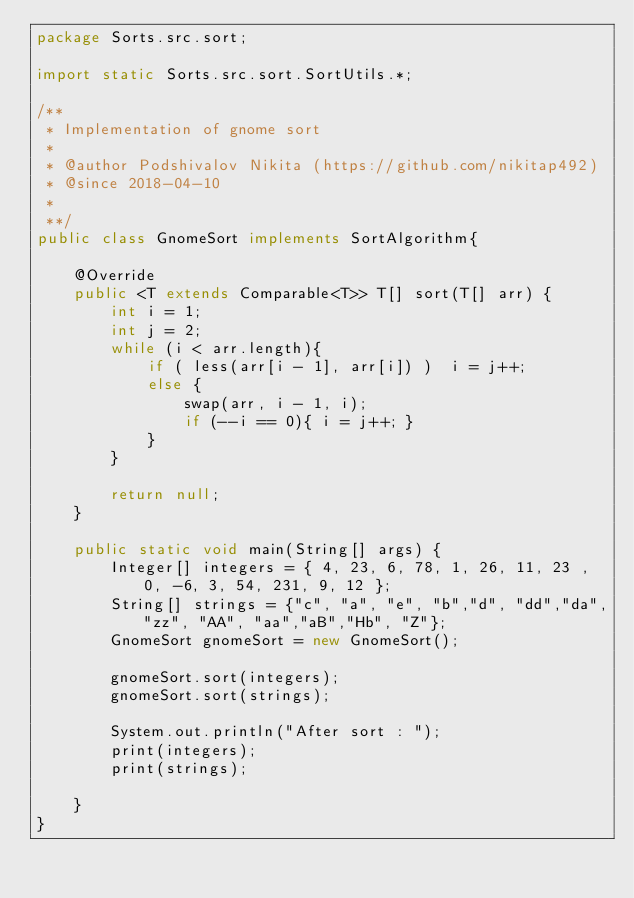Convert code to text. <code><loc_0><loc_0><loc_500><loc_500><_Java_>package Sorts.src.sort;

import static Sorts.src.sort.SortUtils.*;

/**
 * Implementation of gnome sort
 *
 * @author Podshivalov Nikita (https://github.com/nikitap492)
 * @since 2018-04-10
 *
 **/
public class GnomeSort implements SortAlgorithm{

    @Override
    public <T extends Comparable<T>> T[] sort(T[] arr) {
        int i = 1;
        int j = 2;
        while (i < arr.length){
            if ( less(arr[i - 1], arr[i]) )  i = j++;
            else {
                swap(arr, i - 1, i);
                if (--i == 0){ i = j++; }
            }
        }

        return null;
    }

    public static void main(String[] args) {
        Integer[] integers = { 4, 23, 6, 78, 1, 26, 11, 23 , 0, -6, 3, 54, 231, 9, 12 };
        String[] strings = {"c", "a", "e", "b","d", "dd","da","zz", "AA", "aa","aB","Hb", "Z"};
        GnomeSort gnomeSort = new GnomeSort();

        gnomeSort.sort(integers);
        gnomeSort.sort(strings);

        System.out.println("After sort : ");
        print(integers);
        print(strings);

    }
}

</code> 